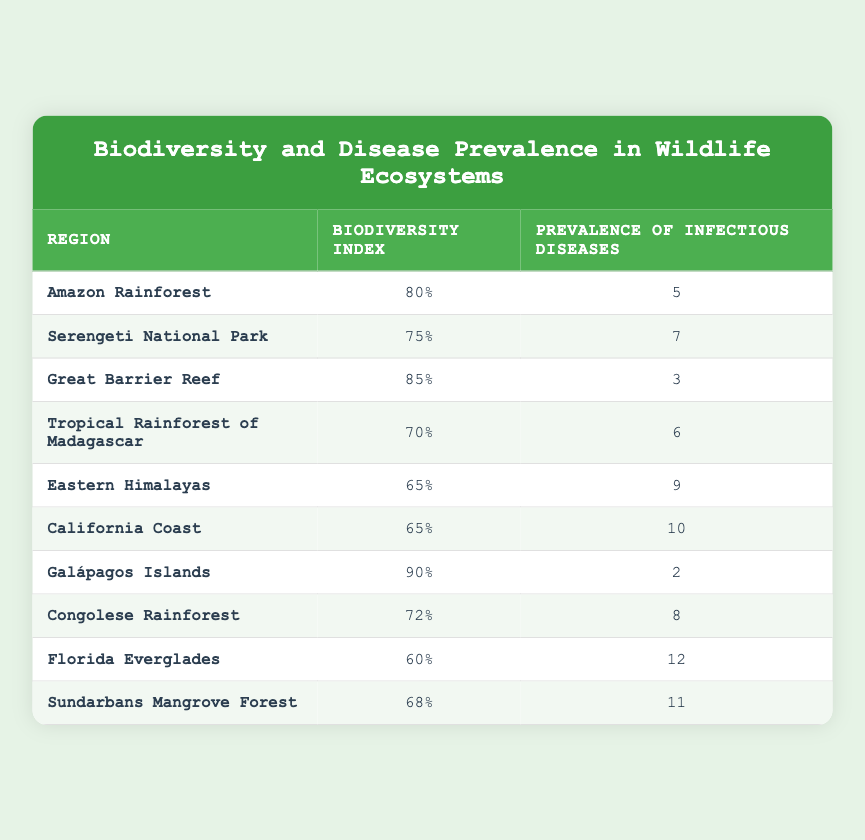What is the biodiversity index of the Galápagos Islands? The table lists the Galápagos Islands and indicates the biodiversity index for this region as 90.
Answer: 90 What is the prevalence of infectious diseases in the Amazon Rainforest? According to the table, the prevalence of infectious diseases in the Amazon Rainforest is stated as 5.
Answer: 5 Which region has the highest biodiversity index? By comparing the biodiversity indices in the table, the highest value is for the Galápagos Islands, which is 90.
Answer: Galápagos Islands Is the prevalence of infectious diseases higher in the Florida Everglades than in the California Coast? The table shows the prevalence in the Florida Everglades as 12 and in the California Coast as 10, so yes, Florida Everglades has a higher prevalence.
Answer: Yes What is the average prevalence of infectious diseases across all regions listed? To calculate the average, sum all the prevalence values (5 + 7 + 3 + 6 + 9 + 10 + 2 + 8 + 12 + 11 = 73) and divide by the number of regions (10). Thus, 73/10 equals 7.3.
Answer: 7.3 Which region or regions have a biodiversity index lower than 70? The regions below a biodiversity index of 70 according to the table are the Eastern Himalayas (65), California Coast (65), Florida Everglades (60), and Sundarbans Mangrove Forest (68).
Answer: Eastern Himalayas, California Coast, Florida Everglades, Sundarbans Mangrove Forest Is it true that regions with higher biodiversity indices tend to have lower prevalence of infectious diseases? Looking at the table, we can observe a trend where regions with higher biodiversity indices (such as the Galápagos Islands with index 90 and prevalence 2) tend to have lower prevalence; however, further analysis would be needed for concrete conclusions. Based on visible data, it's generally true.
Answer: Yes What is the difference in prevalence of infectious diseases between the Great Barrier Reef and the Eastern Himalayas? The Great Barrier Reef has a prevalence of 3, and the Eastern Himalayas have a prevalence of 9. Therefore, the difference is calculated as 9 - 3 = 6.
Answer: 6 Which two regions have the most similar biodiversity indices? The table shows the California Coast and Eastern Himalayas both have biodiversity indices of 65, indicating they are the most similar.
Answer: California Coast and Eastern Himalayas 